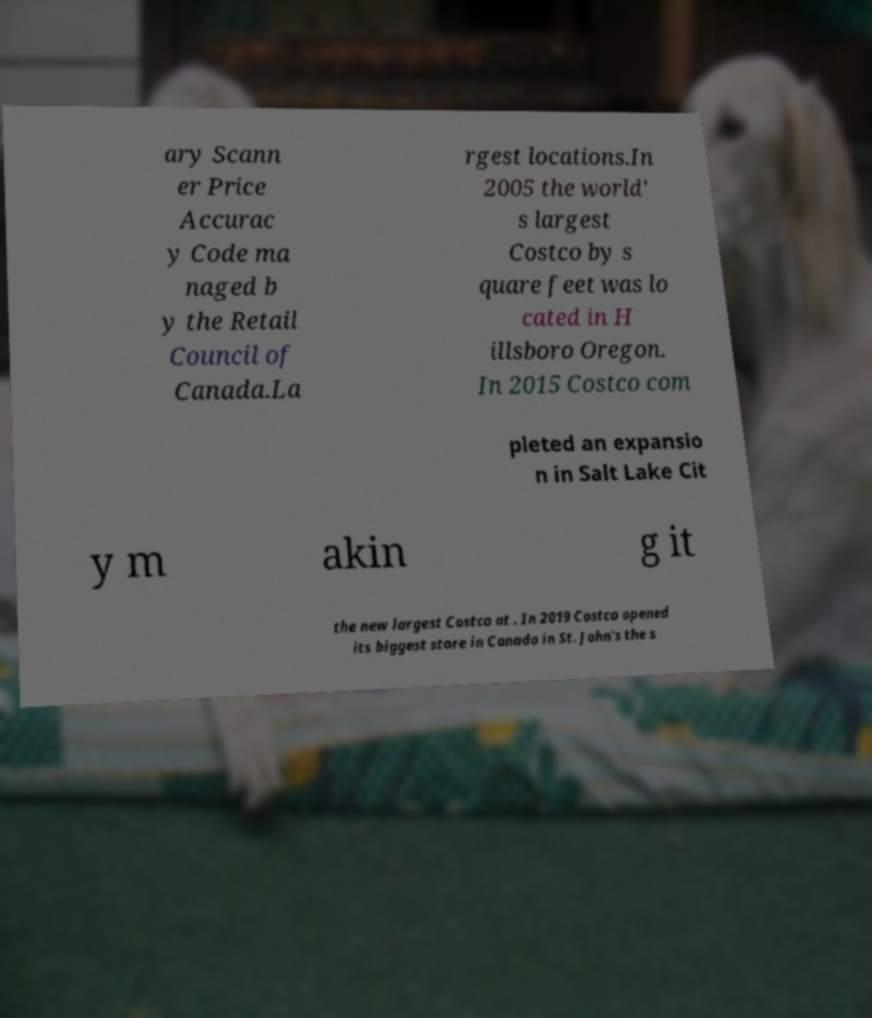Can you read and provide the text displayed in the image?This photo seems to have some interesting text. Can you extract and type it out for me? ary Scann er Price Accurac y Code ma naged b y the Retail Council of Canada.La rgest locations.In 2005 the world' s largest Costco by s quare feet was lo cated in H illsboro Oregon. In 2015 Costco com pleted an expansio n in Salt Lake Cit y m akin g it the new largest Costco at . In 2019 Costco opened its biggest store in Canada in St. John's the s 